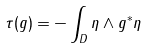<formula> <loc_0><loc_0><loc_500><loc_500>\tau ( g ) = - \int _ { D } \eta \wedge g ^ { \ast } \eta</formula> 